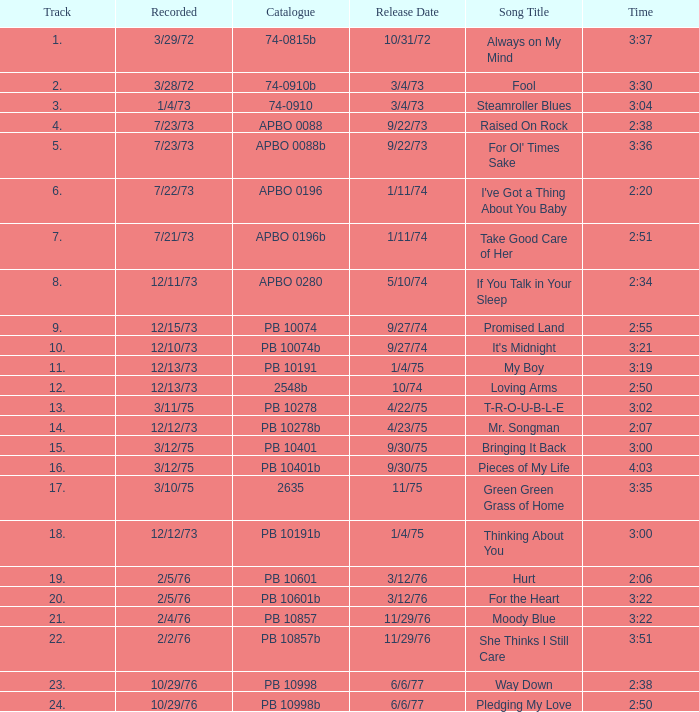Can you provide the count of tracks included in raised on rock? 4.0. 